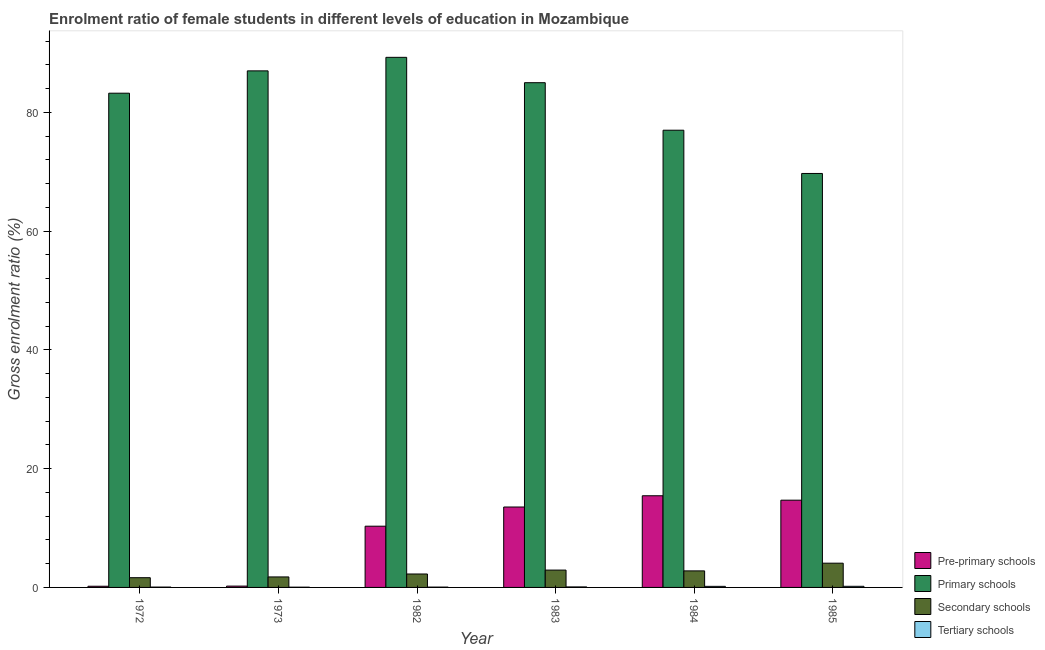How many different coloured bars are there?
Keep it short and to the point. 4. How many groups of bars are there?
Give a very brief answer. 6. Are the number of bars per tick equal to the number of legend labels?
Keep it short and to the point. Yes. How many bars are there on the 4th tick from the left?
Offer a very short reply. 4. How many bars are there on the 2nd tick from the right?
Your answer should be compact. 4. What is the label of the 2nd group of bars from the left?
Make the answer very short. 1973. What is the gross enrolment ratio(male) in primary schools in 1973?
Ensure brevity in your answer.  87. Across all years, what is the maximum gross enrolment ratio(male) in pre-primary schools?
Keep it short and to the point. 15.44. Across all years, what is the minimum gross enrolment ratio(male) in secondary schools?
Ensure brevity in your answer.  1.64. What is the total gross enrolment ratio(male) in pre-primary schools in the graph?
Make the answer very short. 54.41. What is the difference between the gross enrolment ratio(male) in primary schools in 1984 and that in 1985?
Give a very brief answer. 7.28. What is the difference between the gross enrolment ratio(male) in primary schools in 1984 and the gross enrolment ratio(male) in secondary schools in 1973?
Ensure brevity in your answer.  -10. What is the average gross enrolment ratio(male) in primary schools per year?
Your answer should be very brief. 81.88. In the year 1973, what is the difference between the gross enrolment ratio(male) in pre-primary schools and gross enrolment ratio(male) in secondary schools?
Provide a short and direct response. 0. In how many years, is the gross enrolment ratio(male) in secondary schools greater than 16 %?
Your answer should be very brief. 0. What is the ratio of the gross enrolment ratio(male) in tertiary schools in 1972 to that in 1983?
Make the answer very short. 0.68. Is the gross enrolment ratio(male) in pre-primary schools in 1972 less than that in 1983?
Your answer should be very brief. Yes. Is the difference between the gross enrolment ratio(male) in pre-primary schools in 1983 and 1984 greater than the difference between the gross enrolment ratio(male) in secondary schools in 1983 and 1984?
Give a very brief answer. No. What is the difference between the highest and the second highest gross enrolment ratio(male) in tertiary schools?
Keep it short and to the point. 0.01. What is the difference between the highest and the lowest gross enrolment ratio(male) in primary schools?
Make the answer very short. 19.56. Is the sum of the gross enrolment ratio(male) in primary schools in 1973 and 1982 greater than the maximum gross enrolment ratio(male) in tertiary schools across all years?
Provide a succinct answer. Yes. Is it the case that in every year, the sum of the gross enrolment ratio(male) in tertiary schools and gross enrolment ratio(male) in secondary schools is greater than the sum of gross enrolment ratio(male) in primary schools and gross enrolment ratio(male) in pre-primary schools?
Keep it short and to the point. No. What does the 2nd bar from the left in 1982 represents?
Provide a succinct answer. Primary schools. What does the 3rd bar from the right in 1985 represents?
Your answer should be very brief. Primary schools. How many bars are there?
Ensure brevity in your answer.  24. Are all the bars in the graph horizontal?
Ensure brevity in your answer.  No. How many years are there in the graph?
Keep it short and to the point. 6. Does the graph contain grids?
Provide a succinct answer. No. How many legend labels are there?
Your answer should be very brief. 4. What is the title of the graph?
Make the answer very short. Enrolment ratio of female students in different levels of education in Mozambique. What is the label or title of the Y-axis?
Offer a terse response. Gross enrolment ratio (%). What is the Gross enrolment ratio (%) of Pre-primary schools in 1972?
Give a very brief answer. 0.2. What is the Gross enrolment ratio (%) of Primary schools in 1972?
Offer a terse response. 83.24. What is the Gross enrolment ratio (%) of Secondary schools in 1972?
Offer a very short reply. 1.64. What is the Gross enrolment ratio (%) in Tertiary schools in 1972?
Your answer should be very brief. 0.06. What is the Gross enrolment ratio (%) in Pre-primary schools in 1973?
Your response must be concise. 0.22. What is the Gross enrolment ratio (%) in Primary schools in 1973?
Your answer should be compact. 87. What is the Gross enrolment ratio (%) of Secondary schools in 1973?
Make the answer very short. 1.77. What is the Gross enrolment ratio (%) in Tertiary schools in 1973?
Provide a succinct answer. 0.04. What is the Gross enrolment ratio (%) of Pre-primary schools in 1982?
Offer a very short reply. 10.31. What is the Gross enrolment ratio (%) in Primary schools in 1982?
Ensure brevity in your answer.  89.28. What is the Gross enrolment ratio (%) of Secondary schools in 1982?
Your answer should be compact. 2.26. What is the Gross enrolment ratio (%) in Tertiary schools in 1982?
Give a very brief answer. 0.05. What is the Gross enrolment ratio (%) of Pre-primary schools in 1983?
Your answer should be compact. 13.54. What is the Gross enrolment ratio (%) of Primary schools in 1983?
Your response must be concise. 85.01. What is the Gross enrolment ratio (%) of Secondary schools in 1983?
Your response must be concise. 2.92. What is the Gross enrolment ratio (%) of Tertiary schools in 1983?
Your answer should be very brief. 0.09. What is the Gross enrolment ratio (%) of Pre-primary schools in 1984?
Offer a terse response. 15.44. What is the Gross enrolment ratio (%) in Primary schools in 1984?
Provide a short and direct response. 77. What is the Gross enrolment ratio (%) of Secondary schools in 1984?
Make the answer very short. 2.79. What is the Gross enrolment ratio (%) of Tertiary schools in 1984?
Offer a very short reply. 0.18. What is the Gross enrolment ratio (%) in Pre-primary schools in 1985?
Keep it short and to the point. 14.7. What is the Gross enrolment ratio (%) of Primary schools in 1985?
Ensure brevity in your answer.  69.72. What is the Gross enrolment ratio (%) in Secondary schools in 1985?
Keep it short and to the point. 4.08. What is the Gross enrolment ratio (%) of Tertiary schools in 1985?
Make the answer very short. 0.19. Across all years, what is the maximum Gross enrolment ratio (%) in Pre-primary schools?
Your answer should be very brief. 15.44. Across all years, what is the maximum Gross enrolment ratio (%) in Primary schools?
Provide a short and direct response. 89.28. Across all years, what is the maximum Gross enrolment ratio (%) in Secondary schools?
Offer a very short reply. 4.08. Across all years, what is the maximum Gross enrolment ratio (%) in Tertiary schools?
Ensure brevity in your answer.  0.19. Across all years, what is the minimum Gross enrolment ratio (%) of Pre-primary schools?
Your response must be concise. 0.2. Across all years, what is the minimum Gross enrolment ratio (%) of Primary schools?
Ensure brevity in your answer.  69.72. Across all years, what is the minimum Gross enrolment ratio (%) in Secondary schools?
Provide a short and direct response. 1.64. Across all years, what is the minimum Gross enrolment ratio (%) of Tertiary schools?
Ensure brevity in your answer.  0.04. What is the total Gross enrolment ratio (%) of Pre-primary schools in the graph?
Your answer should be compact. 54.41. What is the total Gross enrolment ratio (%) of Primary schools in the graph?
Give a very brief answer. 491.25. What is the total Gross enrolment ratio (%) in Secondary schools in the graph?
Provide a short and direct response. 15.46. What is the total Gross enrolment ratio (%) of Tertiary schools in the graph?
Provide a succinct answer. 0.61. What is the difference between the Gross enrolment ratio (%) in Pre-primary schools in 1972 and that in 1973?
Keep it short and to the point. -0.02. What is the difference between the Gross enrolment ratio (%) in Primary schools in 1972 and that in 1973?
Offer a terse response. -3.76. What is the difference between the Gross enrolment ratio (%) in Secondary schools in 1972 and that in 1973?
Provide a short and direct response. -0.13. What is the difference between the Gross enrolment ratio (%) of Tertiary schools in 1972 and that in 1973?
Provide a short and direct response. 0.02. What is the difference between the Gross enrolment ratio (%) in Pre-primary schools in 1972 and that in 1982?
Offer a very short reply. -10.11. What is the difference between the Gross enrolment ratio (%) in Primary schools in 1972 and that in 1982?
Your answer should be compact. -6.04. What is the difference between the Gross enrolment ratio (%) in Secondary schools in 1972 and that in 1982?
Provide a short and direct response. -0.62. What is the difference between the Gross enrolment ratio (%) of Tertiary schools in 1972 and that in 1982?
Give a very brief answer. 0. What is the difference between the Gross enrolment ratio (%) of Pre-primary schools in 1972 and that in 1983?
Your response must be concise. -13.34. What is the difference between the Gross enrolment ratio (%) in Primary schools in 1972 and that in 1983?
Make the answer very short. -1.77. What is the difference between the Gross enrolment ratio (%) in Secondary schools in 1972 and that in 1983?
Your response must be concise. -1.28. What is the difference between the Gross enrolment ratio (%) in Tertiary schools in 1972 and that in 1983?
Make the answer very short. -0.03. What is the difference between the Gross enrolment ratio (%) in Pre-primary schools in 1972 and that in 1984?
Your response must be concise. -15.24. What is the difference between the Gross enrolment ratio (%) of Primary schools in 1972 and that in 1984?
Your answer should be very brief. 6.24. What is the difference between the Gross enrolment ratio (%) of Secondary schools in 1972 and that in 1984?
Your answer should be very brief. -1.15. What is the difference between the Gross enrolment ratio (%) in Tertiary schools in 1972 and that in 1984?
Give a very brief answer. -0.12. What is the difference between the Gross enrolment ratio (%) in Pre-primary schools in 1972 and that in 1985?
Keep it short and to the point. -14.5. What is the difference between the Gross enrolment ratio (%) of Primary schools in 1972 and that in 1985?
Make the answer very short. 13.52. What is the difference between the Gross enrolment ratio (%) of Secondary schools in 1972 and that in 1985?
Your answer should be very brief. -2.44. What is the difference between the Gross enrolment ratio (%) of Tertiary schools in 1972 and that in 1985?
Ensure brevity in your answer.  -0.13. What is the difference between the Gross enrolment ratio (%) in Pre-primary schools in 1973 and that in 1982?
Ensure brevity in your answer.  -10.09. What is the difference between the Gross enrolment ratio (%) of Primary schools in 1973 and that in 1982?
Give a very brief answer. -2.28. What is the difference between the Gross enrolment ratio (%) in Secondary schools in 1973 and that in 1982?
Your response must be concise. -0.5. What is the difference between the Gross enrolment ratio (%) of Tertiary schools in 1973 and that in 1982?
Offer a very short reply. -0.01. What is the difference between the Gross enrolment ratio (%) in Pre-primary schools in 1973 and that in 1983?
Provide a short and direct response. -13.32. What is the difference between the Gross enrolment ratio (%) in Primary schools in 1973 and that in 1983?
Provide a succinct answer. 1.99. What is the difference between the Gross enrolment ratio (%) of Secondary schools in 1973 and that in 1983?
Provide a succinct answer. -1.15. What is the difference between the Gross enrolment ratio (%) of Tertiary schools in 1973 and that in 1983?
Provide a succinct answer. -0.04. What is the difference between the Gross enrolment ratio (%) in Pre-primary schools in 1973 and that in 1984?
Your answer should be very brief. -15.22. What is the difference between the Gross enrolment ratio (%) of Primary schools in 1973 and that in 1984?
Give a very brief answer. 10. What is the difference between the Gross enrolment ratio (%) of Secondary schools in 1973 and that in 1984?
Offer a terse response. -1.02. What is the difference between the Gross enrolment ratio (%) in Tertiary schools in 1973 and that in 1984?
Provide a succinct answer. -0.14. What is the difference between the Gross enrolment ratio (%) of Pre-primary schools in 1973 and that in 1985?
Offer a terse response. -14.47. What is the difference between the Gross enrolment ratio (%) in Primary schools in 1973 and that in 1985?
Ensure brevity in your answer.  17.28. What is the difference between the Gross enrolment ratio (%) of Secondary schools in 1973 and that in 1985?
Give a very brief answer. -2.31. What is the difference between the Gross enrolment ratio (%) of Tertiary schools in 1973 and that in 1985?
Your answer should be very brief. -0.15. What is the difference between the Gross enrolment ratio (%) of Pre-primary schools in 1982 and that in 1983?
Your answer should be compact. -3.23. What is the difference between the Gross enrolment ratio (%) of Primary schools in 1982 and that in 1983?
Offer a very short reply. 4.27. What is the difference between the Gross enrolment ratio (%) in Secondary schools in 1982 and that in 1983?
Keep it short and to the point. -0.66. What is the difference between the Gross enrolment ratio (%) of Tertiary schools in 1982 and that in 1983?
Make the answer very short. -0.03. What is the difference between the Gross enrolment ratio (%) of Pre-primary schools in 1982 and that in 1984?
Give a very brief answer. -5.12. What is the difference between the Gross enrolment ratio (%) in Primary schools in 1982 and that in 1984?
Offer a terse response. 12.27. What is the difference between the Gross enrolment ratio (%) of Secondary schools in 1982 and that in 1984?
Offer a very short reply. -0.52. What is the difference between the Gross enrolment ratio (%) in Tertiary schools in 1982 and that in 1984?
Your answer should be very brief. -0.13. What is the difference between the Gross enrolment ratio (%) in Pre-primary schools in 1982 and that in 1985?
Make the answer very short. -4.38. What is the difference between the Gross enrolment ratio (%) of Primary schools in 1982 and that in 1985?
Keep it short and to the point. 19.56. What is the difference between the Gross enrolment ratio (%) in Secondary schools in 1982 and that in 1985?
Provide a short and direct response. -1.82. What is the difference between the Gross enrolment ratio (%) of Tertiary schools in 1982 and that in 1985?
Your response must be concise. -0.14. What is the difference between the Gross enrolment ratio (%) of Pre-primary schools in 1983 and that in 1984?
Give a very brief answer. -1.89. What is the difference between the Gross enrolment ratio (%) of Primary schools in 1983 and that in 1984?
Your response must be concise. 8. What is the difference between the Gross enrolment ratio (%) in Secondary schools in 1983 and that in 1984?
Give a very brief answer. 0.13. What is the difference between the Gross enrolment ratio (%) in Tertiary schools in 1983 and that in 1984?
Provide a succinct answer. -0.1. What is the difference between the Gross enrolment ratio (%) in Pre-primary schools in 1983 and that in 1985?
Provide a succinct answer. -1.15. What is the difference between the Gross enrolment ratio (%) of Primary schools in 1983 and that in 1985?
Offer a terse response. 15.29. What is the difference between the Gross enrolment ratio (%) of Secondary schools in 1983 and that in 1985?
Provide a short and direct response. -1.16. What is the difference between the Gross enrolment ratio (%) of Tertiary schools in 1983 and that in 1985?
Offer a very short reply. -0.1. What is the difference between the Gross enrolment ratio (%) of Pre-primary schools in 1984 and that in 1985?
Provide a succinct answer. 0.74. What is the difference between the Gross enrolment ratio (%) of Primary schools in 1984 and that in 1985?
Provide a short and direct response. 7.28. What is the difference between the Gross enrolment ratio (%) in Secondary schools in 1984 and that in 1985?
Provide a succinct answer. -1.3. What is the difference between the Gross enrolment ratio (%) in Tertiary schools in 1984 and that in 1985?
Offer a terse response. -0.01. What is the difference between the Gross enrolment ratio (%) of Pre-primary schools in 1972 and the Gross enrolment ratio (%) of Primary schools in 1973?
Ensure brevity in your answer.  -86.8. What is the difference between the Gross enrolment ratio (%) of Pre-primary schools in 1972 and the Gross enrolment ratio (%) of Secondary schools in 1973?
Provide a succinct answer. -1.57. What is the difference between the Gross enrolment ratio (%) in Pre-primary schools in 1972 and the Gross enrolment ratio (%) in Tertiary schools in 1973?
Give a very brief answer. 0.16. What is the difference between the Gross enrolment ratio (%) in Primary schools in 1972 and the Gross enrolment ratio (%) in Secondary schools in 1973?
Make the answer very short. 81.47. What is the difference between the Gross enrolment ratio (%) of Primary schools in 1972 and the Gross enrolment ratio (%) of Tertiary schools in 1973?
Provide a succinct answer. 83.2. What is the difference between the Gross enrolment ratio (%) in Secondary schools in 1972 and the Gross enrolment ratio (%) in Tertiary schools in 1973?
Make the answer very short. 1.6. What is the difference between the Gross enrolment ratio (%) in Pre-primary schools in 1972 and the Gross enrolment ratio (%) in Primary schools in 1982?
Offer a very short reply. -89.08. What is the difference between the Gross enrolment ratio (%) of Pre-primary schools in 1972 and the Gross enrolment ratio (%) of Secondary schools in 1982?
Your answer should be compact. -2.06. What is the difference between the Gross enrolment ratio (%) of Pre-primary schools in 1972 and the Gross enrolment ratio (%) of Tertiary schools in 1982?
Give a very brief answer. 0.15. What is the difference between the Gross enrolment ratio (%) in Primary schools in 1972 and the Gross enrolment ratio (%) in Secondary schools in 1982?
Give a very brief answer. 80.98. What is the difference between the Gross enrolment ratio (%) in Primary schools in 1972 and the Gross enrolment ratio (%) in Tertiary schools in 1982?
Give a very brief answer. 83.19. What is the difference between the Gross enrolment ratio (%) in Secondary schools in 1972 and the Gross enrolment ratio (%) in Tertiary schools in 1982?
Provide a succinct answer. 1.58. What is the difference between the Gross enrolment ratio (%) in Pre-primary schools in 1972 and the Gross enrolment ratio (%) in Primary schools in 1983?
Keep it short and to the point. -84.81. What is the difference between the Gross enrolment ratio (%) of Pre-primary schools in 1972 and the Gross enrolment ratio (%) of Secondary schools in 1983?
Your answer should be very brief. -2.72. What is the difference between the Gross enrolment ratio (%) of Pre-primary schools in 1972 and the Gross enrolment ratio (%) of Tertiary schools in 1983?
Offer a very short reply. 0.11. What is the difference between the Gross enrolment ratio (%) of Primary schools in 1972 and the Gross enrolment ratio (%) of Secondary schools in 1983?
Keep it short and to the point. 80.32. What is the difference between the Gross enrolment ratio (%) of Primary schools in 1972 and the Gross enrolment ratio (%) of Tertiary schools in 1983?
Offer a very short reply. 83.15. What is the difference between the Gross enrolment ratio (%) in Secondary schools in 1972 and the Gross enrolment ratio (%) in Tertiary schools in 1983?
Give a very brief answer. 1.55. What is the difference between the Gross enrolment ratio (%) in Pre-primary schools in 1972 and the Gross enrolment ratio (%) in Primary schools in 1984?
Your answer should be very brief. -76.8. What is the difference between the Gross enrolment ratio (%) in Pre-primary schools in 1972 and the Gross enrolment ratio (%) in Secondary schools in 1984?
Offer a terse response. -2.59. What is the difference between the Gross enrolment ratio (%) of Pre-primary schools in 1972 and the Gross enrolment ratio (%) of Tertiary schools in 1984?
Offer a very short reply. 0.02. What is the difference between the Gross enrolment ratio (%) of Primary schools in 1972 and the Gross enrolment ratio (%) of Secondary schools in 1984?
Provide a short and direct response. 80.45. What is the difference between the Gross enrolment ratio (%) in Primary schools in 1972 and the Gross enrolment ratio (%) in Tertiary schools in 1984?
Provide a succinct answer. 83.06. What is the difference between the Gross enrolment ratio (%) of Secondary schools in 1972 and the Gross enrolment ratio (%) of Tertiary schools in 1984?
Keep it short and to the point. 1.46. What is the difference between the Gross enrolment ratio (%) of Pre-primary schools in 1972 and the Gross enrolment ratio (%) of Primary schools in 1985?
Offer a terse response. -69.52. What is the difference between the Gross enrolment ratio (%) in Pre-primary schools in 1972 and the Gross enrolment ratio (%) in Secondary schools in 1985?
Offer a very short reply. -3.88. What is the difference between the Gross enrolment ratio (%) of Pre-primary schools in 1972 and the Gross enrolment ratio (%) of Tertiary schools in 1985?
Ensure brevity in your answer.  0.01. What is the difference between the Gross enrolment ratio (%) of Primary schools in 1972 and the Gross enrolment ratio (%) of Secondary schools in 1985?
Provide a short and direct response. 79.16. What is the difference between the Gross enrolment ratio (%) in Primary schools in 1972 and the Gross enrolment ratio (%) in Tertiary schools in 1985?
Your answer should be very brief. 83.05. What is the difference between the Gross enrolment ratio (%) in Secondary schools in 1972 and the Gross enrolment ratio (%) in Tertiary schools in 1985?
Provide a short and direct response. 1.45. What is the difference between the Gross enrolment ratio (%) of Pre-primary schools in 1973 and the Gross enrolment ratio (%) of Primary schools in 1982?
Your answer should be very brief. -89.06. What is the difference between the Gross enrolment ratio (%) of Pre-primary schools in 1973 and the Gross enrolment ratio (%) of Secondary schools in 1982?
Your answer should be very brief. -2.04. What is the difference between the Gross enrolment ratio (%) of Pre-primary schools in 1973 and the Gross enrolment ratio (%) of Tertiary schools in 1982?
Make the answer very short. 0.17. What is the difference between the Gross enrolment ratio (%) of Primary schools in 1973 and the Gross enrolment ratio (%) of Secondary schools in 1982?
Offer a very short reply. 84.74. What is the difference between the Gross enrolment ratio (%) in Primary schools in 1973 and the Gross enrolment ratio (%) in Tertiary schools in 1982?
Your answer should be very brief. 86.95. What is the difference between the Gross enrolment ratio (%) in Secondary schools in 1973 and the Gross enrolment ratio (%) in Tertiary schools in 1982?
Your answer should be compact. 1.71. What is the difference between the Gross enrolment ratio (%) in Pre-primary schools in 1973 and the Gross enrolment ratio (%) in Primary schools in 1983?
Make the answer very short. -84.79. What is the difference between the Gross enrolment ratio (%) of Pre-primary schools in 1973 and the Gross enrolment ratio (%) of Secondary schools in 1983?
Provide a short and direct response. -2.7. What is the difference between the Gross enrolment ratio (%) of Pre-primary schools in 1973 and the Gross enrolment ratio (%) of Tertiary schools in 1983?
Keep it short and to the point. 0.14. What is the difference between the Gross enrolment ratio (%) in Primary schools in 1973 and the Gross enrolment ratio (%) in Secondary schools in 1983?
Your answer should be compact. 84.08. What is the difference between the Gross enrolment ratio (%) in Primary schools in 1973 and the Gross enrolment ratio (%) in Tertiary schools in 1983?
Your response must be concise. 86.91. What is the difference between the Gross enrolment ratio (%) of Secondary schools in 1973 and the Gross enrolment ratio (%) of Tertiary schools in 1983?
Provide a succinct answer. 1.68. What is the difference between the Gross enrolment ratio (%) in Pre-primary schools in 1973 and the Gross enrolment ratio (%) in Primary schools in 1984?
Make the answer very short. -76.78. What is the difference between the Gross enrolment ratio (%) in Pre-primary schools in 1973 and the Gross enrolment ratio (%) in Secondary schools in 1984?
Your answer should be compact. -2.56. What is the difference between the Gross enrolment ratio (%) of Pre-primary schools in 1973 and the Gross enrolment ratio (%) of Tertiary schools in 1984?
Your answer should be very brief. 0.04. What is the difference between the Gross enrolment ratio (%) of Primary schools in 1973 and the Gross enrolment ratio (%) of Secondary schools in 1984?
Your response must be concise. 84.21. What is the difference between the Gross enrolment ratio (%) in Primary schools in 1973 and the Gross enrolment ratio (%) in Tertiary schools in 1984?
Offer a terse response. 86.82. What is the difference between the Gross enrolment ratio (%) of Secondary schools in 1973 and the Gross enrolment ratio (%) of Tertiary schools in 1984?
Offer a very short reply. 1.59. What is the difference between the Gross enrolment ratio (%) of Pre-primary schools in 1973 and the Gross enrolment ratio (%) of Primary schools in 1985?
Your response must be concise. -69.5. What is the difference between the Gross enrolment ratio (%) of Pre-primary schools in 1973 and the Gross enrolment ratio (%) of Secondary schools in 1985?
Offer a very short reply. -3.86. What is the difference between the Gross enrolment ratio (%) of Pre-primary schools in 1973 and the Gross enrolment ratio (%) of Tertiary schools in 1985?
Offer a terse response. 0.03. What is the difference between the Gross enrolment ratio (%) in Primary schools in 1973 and the Gross enrolment ratio (%) in Secondary schools in 1985?
Provide a short and direct response. 82.92. What is the difference between the Gross enrolment ratio (%) in Primary schools in 1973 and the Gross enrolment ratio (%) in Tertiary schools in 1985?
Your answer should be compact. 86.81. What is the difference between the Gross enrolment ratio (%) of Secondary schools in 1973 and the Gross enrolment ratio (%) of Tertiary schools in 1985?
Offer a terse response. 1.58. What is the difference between the Gross enrolment ratio (%) of Pre-primary schools in 1982 and the Gross enrolment ratio (%) of Primary schools in 1983?
Provide a succinct answer. -74.69. What is the difference between the Gross enrolment ratio (%) in Pre-primary schools in 1982 and the Gross enrolment ratio (%) in Secondary schools in 1983?
Your answer should be very brief. 7.39. What is the difference between the Gross enrolment ratio (%) in Pre-primary schools in 1982 and the Gross enrolment ratio (%) in Tertiary schools in 1983?
Provide a succinct answer. 10.23. What is the difference between the Gross enrolment ratio (%) in Primary schools in 1982 and the Gross enrolment ratio (%) in Secondary schools in 1983?
Provide a short and direct response. 86.36. What is the difference between the Gross enrolment ratio (%) of Primary schools in 1982 and the Gross enrolment ratio (%) of Tertiary schools in 1983?
Provide a short and direct response. 89.19. What is the difference between the Gross enrolment ratio (%) in Secondary schools in 1982 and the Gross enrolment ratio (%) in Tertiary schools in 1983?
Your answer should be compact. 2.18. What is the difference between the Gross enrolment ratio (%) of Pre-primary schools in 1982 and the Gross enrolment ratio (%) of Primary schools in 1984?
Your answer should be very brief. -66.69. What is the difference between the Gross enrolment ratio (%) of Pre-primary schools in 1982 and the Gross enrolment ratio (%) of Secondary schools in 1984?
Provide a succinct answer. 7.53. What is the difference between the Gross enrolment ratio (%) of Pre-primary schools in 1982 and the Gross enrolment ratio (%) of Tertiary schools in 1984?
Your response must be concise. 10.13. What is the difference between the Gross enrolment ratio (%) in Primary schools in 1982 and the Gross enrolment ratio (%) in Secondary schools in 1984?
Give a very brief answer. 86.49. What is the difference between the Gross enrolment ratio (%) of Primary schools in 1982 and the Gross enrolment ratio (%) of Tertiary schools in 1984?
Your answer should be very brief. 89.1. What is the difference between the Gross enrolment ratio (%) of Secondary schools in 1982 and the Gross enrolment ratio (%) of Tertiary schools in 1984?
Offer a terse response. 2.08. What is the difference between the Gross enrolment ratio (%) of Pre-primary schools in 1982 and the Gross enrolment ratio (%) of Primary schools in 1985?
Make the answer very short. -59.41. What is the difference between the Gross enrolment ratio (%) in Pre-primary schools in 1982 and the Gross enrolment ratio (%) in Secondary schools in 1985?
Ensure brevity in your answer.  6.23. What is the difference between the Gross enrolment ratio (%) of Pre-primary schools in 1982 and the Gross enrolment ratio (%) of Tertiary schools in 1985?
Provide a succinct answer. 10.12. What is the difference between the Gross enrolment ratio (%) of Primary schools in 1982 and the Gross enrolment ratio (%) of Secondary schools in 1985?
Your response must be concise. 85.2. What is the difference between the Gross enrolment ratio (%) in Primary schools in 1982 and the Gross enrolment ratio (%) in Tertiary schools in 1985?
Ensure brevity in your answer.  89.09. What is the difference between the Gross enrolment ratio (%) in Secondary schools in 1982 and the Gross enrolment ratio (%) in Tertiary schools in 1985?
Provide a short and direct response. 2.07. What is the difference between the Gross enrolment ratio (%) in Pre-primary schools in 1983 and the Gross enrolment ratio (%) in Primary schools in 1984?
Keep it short and to the point. -63.46. What is the difference between the Gross enrolment ratio (%) of Pre-primary schools in 1983 and the Gross enrolment ratio (%) of Secondary schools in 1984?
Keep it short and to the point. 10.76. What is the difference between the Gross enrolment ratio (%) in Pre-primary schools in 1983 and the Gross enrolment ratio (%) in Tertiary schools in 1984?
Make the answer very short. 13.36. What is the difference between the Gross enrolment ratio (%) of Primary schools in 1983 and the Gross enrolment ratio (%) of Secondary schools in 1984?
Make the answer very short. 82.22. What is the difference between the Gross enrolment ratio (%) in Primary schools in 1983 and the Gross enrolment ratio (%) in Tertiary schools in 1984?
Provide a succinct answer. 84.83. What is the difference between the Gross enrolment ratio (%) in Secondary schools in 1983 and the Gross enrolment ratio (%) in Tertiary schools in 1984?
Make the answer very short. 2.74. What is the difference between the Gross enrolment ratio (%) in Pre-primary schools in 1983 and the Gross enrolment ratio (%) in Primary schools in 1985?
Ensure brevity in your answer.  -56.18. What is the difference between the Gross enrolment ratio (%) of Pre-primary schools in 1983 and the Gross enrolment ratio (%) of Secondary schools in 1985?
Your response must be concise. 9.46. What is the difference between the Gross enrolment ratio (%) in Pre-primary schools in 1983 and the Gross enrolment ratio (%) in Tertiary schools in 1985?
Ensure brevity in your answer.  13.35. What is the difference between the Gross enrolment ratio (%) in Primary schools in 1983 and the Gross enrolment ratio (%) in Secondary schools in 1985?
Ensure brevity in your answer.  80.93. What is the difference between the Gross enrolment ratio (%) of Primary schools in 1983 and the Gross enrolment ratio (%) of Tertiary schools in 1985?
Your response must be concise. 84.82. What is the difference between the Gross enrolment ratio (%) in Secondary schools in 1983 and the Gross enrolment ratio (%) in Tertiary schools in 1985?
Your answer should be compact. 2.73. What is the difference between the Gross enrolment ratio (%) of Pre-primary schools in 1984 and the Gross enrolment ratio (%) of Primary schools in 1985?
Your answer should be very brief. -54.28. What is the difference between the Gross enrolment ratio (%) of Pre-primary schools in 1984 and the Gross enrolment ratio (%) of Secondary schools in 1985?
Give a very brief answer. 11.36. What is the difference between the Gross enrolment ratio (%) in Pre-primary schools in 1984 and the Gross enrolment ratio (%) in Tertiary schools in 1985?
Your answer should be compact. 15.25. What is the difference between the Gross enrolment ratio (%) of Primary schools in 1984 and the Gross enrolment ratio (%) of Secondary schools in 1985?
Offer a very short reply. 72.92. What is the difference between the Gross enrolment ratio (%) of Primary schools in 1984 and the Gross enrolment ratio (%) of Tertiary schools in 1985?
Your answer should be compact. 76.81. What is the difference between the Gross enrolment ratio (%) in Secondary schools in 1984 and the Gross enrolment ratio (%) in Tertiary schools in 1985?
Your answer should be very brief. 2.6. What is the average Gross enrolment ratio (%) in Pre-primary schools per year?
Your response must be concise. 9.07. What is the average Gross enrolment ratio (%) in Primary schools per year?
Ensure brevity in your answer.  81.88. What is the average Gross enrolment ratio (%) in Secondary schools per year?
Your response must be concise. 2.58. What is the average Gross enrolment ratio (%) in Tertiary schools per year?
Your response must be concise. 0.1. In the year 1972, what is the difference between the Gross enrolment ratio (%) of Pre-primary schools and Gross enrolment ratio (%) of Primary schools?
Your answer should be compact. -83.04. In the year 1972, what is the difference between the Gross enrolment ratio (%) of Pre-primary schools and Gross enrolment ratio (%) of Secondary schools?
Ensure brevity in your answer.  -1.44. In the year 1972, what is the difference between the Gross enrolment ratio (%) in Pre-primary schools and Gross enrolment ratio (%) in Tertiary schools?
Offer a very short reply. 0.14. In the year 1972, what is the difference between the Gross enrolment ratio (%) of Primary schools and Gross enrolment ratio (%) of Secondary schools?
Your answer should be compact. 81.6. In the year 1972, what is the difference between the Gross enrolment ratio (%) in Primary schools and Gross enrolment ratio (%) in Tertiary schools?
Make the answer very short. 83.18. In the year 1972, what is the difference between the Gross enrolment ratio (%) of Secondary schools and Gross enrolment ratio (%) of Tertiary schools?
Make the answer very short. 1.58. In the year 1973, what is the difference between the Gross enrolment ratio (%) in Pre-primary schools and Gross enrolment ratio (%) in Primary schools?
Your answer should be very brief. -86.78. In the year 1973, what is the difference between the Gross enrolment ratio (%) in Pre-primary schools and Gross enrolment ratio (%) in Secondary schools?
Offer a very short reply. -1.55. In the year 1973, what is the difference between the Gross enrolment ratio (%) of Pre-primary schools and Gross enrolment ratio (%) of Tertiary schools?
Your answer should be compact. 0.18. In the year 1973, what is the difference between the Gross enrolment ratio (%) in Primary schools and Gross enrolment ratio (%) in Secondary schools?
Give a very brief answer. 85.23. In the year 1973, what is the difference between the Gross enrolment ratio (%) of Primary schools and Gross enrolment ratio (%) of Tertiary schools?
Your response must be concise. 86.96. In the year 1973, what is the difference between the Gross enrolment ratio (%) of Secondary schools and Gross enrolment ratio (%) of Tertiary schools?
Offer a terse response. 1.73. In the year 1982, what is the difference between the Gross enrolment ratio (%) of Pre-primary schools and Gross enrolment ratio (%) of Primary schools?
Provide a short and direct response. -78.97. In the year 1982, what is the difference between the Gross enrolment ratio (%) of Pre-primary schools and Gross enrolment ratio (%) of Secondary schools?
Offer a very short reply. 8.05. In the year 1982, what is the difference between the Gross enrolment ratio (%) in Pre-primary schools and Gross enrolment ratio (%) in Tertiary schools?
Your answer should be very brief. 10.26. In the year 1982, what is the difference between the Gross enrolment ratio (%) of Primary schools and Gross enrolment ratio (%) of Secondary schools?
Provide a succinct answer. 87.02. In the year 1982, what is the difference between the Gross enrolment ratio (%) in Primary schools and Gross enrolment ratio (%) in Tertiary schools?
Your response must be concise. 89.23. In the year 1982, what is the difference between the Gross enrolment ratio (%) in Secondary schools and Gross enrolment ratio (%) in Tertiary schools?
Give a very brief answer. 2.21. In the year 1983, what is the difference between the Gross enrolment ratio (%) in Pre-primary schools and Gross enrolment ratio (%) in Primary schools?
Offer a terse response. -71.46. In the year 1983, what is the difference between the Gross enrolment ratio (%) in Pre-primary schools and Gross enrolment ratio (%) in Secondary schools?
Ensure brevity in your answer.  10.62. In the year 1983, what is the difference between the Gross enrolment ratio (%) of Pre-primary schools and Gross enrolment ratio (%) of Tertiary schools?
Your answer should be very brief. 13.46. In the year 1983, what is the difference between the Gross enrolment ratio (%) in Primary schools and Gross enrolment ratio (%) in Secondary schools?
Offer a very short reply. 82.09. In the year 1983, what is the difference between the Gross enrolment ratio (%) in Primary schools and Gross enrolment ratio (%) in Tertiary schools?
Keep it short and to the point. 84.92. In the year 1983, what is the difference between the Gross enrolment ratio (%) in Secondary schools and Gross enrolment ratio (%) in Tertiary schools?
Your response must be concise. 2.83. In the year 1984, what is the difference between the Gross enrolment ratio (%) in Pre-primary schools and Gross enrolment ratio (%) in Primary schools?
Your response must be concise. -61.57. In the year 1984, what is the difference between the Gross enrolment ratio (%) of Pre-primary schools and Gross enrolment ratio (%) of Secondary schools?
Your answer should be compact. 12.65. In the year 1984, what is the difference between the Gross enrolment ratio (%) in Pre-primary schools and Gross enrolment ratio (%) in Tertiary schools?
Ensure brevity in your answer.  15.26. In the year 1984, what is the difference between the Gross enrolment ratio (%) in Primary schools and Gross enrolment ratio (%) in Secondary schools?
Your answer should be compact. 74.22. In the year 1984, what is the difference between the Gross enrolment ratio (%) of Primary schools and Gross enrolment ratio (%) of Tertiary schools?
Your answer should be very brief. 76.82. In the year 1984, what is the difference between the Gross enrolment ratio (%) of Secondary schools and Gross enrolment ratio (%) of Tertiary schools?
Keep it short and to the point. 2.6. In the year 1985, what is the difference between the Gross enrolment ratio (%) of Pre-primary schools and Gross enrolment ratio (%) of Primary schools?
Make the answer very short. -55.02. In the year 1985, what is the difference between the Gross enrolment ratio (%) in Pre-primary schools and Gross enrolment ratio (%) in Secondary schools?
Keep it short and to the point. 10.61. In the year 1985, what is the difference between the Gross enrolment ratio (%) in Pre-primary schools and Gross enrolment ratio (%) in Tertiary schools?
Make the answer very short. 14.51. In the year 1985, what is the difference between the Gross enrolment ratio (%) of Primary schools and Gross enrolment ratio (%) of Secondary schools?
Make the answer very short. 65.64. In the year 1985, what is the difference between the Gross enrolment ratio (%) of Primary schools and Gross enrolment ratio (%) of Tertiary schools?
Offer a very short reply. 69.53. In the year 1985, what is the difference between the Gross enrolment ratio (%) in Secondary schools and Gross enrolment ratio (%) in Tertiary schools?
Your answer should be very brief. 3.89. What is the ratio of the Gross enrolment ratio (%) of Pre-primary schools in 1972 to that in 1973?
Offer a terse response. 0.9. What is the ratio of the Gross enrolment ratio (%) in Primary schools in 1972 to that in 1973?
Your answer should be compact. 0.96. What is the ratio of the Gross enrolment ratio (%) in Secondary schools in 1972 to that in 1973?
Offer a terse response. 0.93. What is the ratio of the Gross enrolment ratio (%) of Tertiary schools in 1972 to that in 1973?
Ensure brevity in your answer.  1.42. What is the ratio of the Gross enrolment ratio (%) of Pre-primary schools in 1972 to that in 1982?
Your answer should be very brief. 0.02. What is the ratio of the Gross enrolment ratio (%) in Primary schools in 1972 to that in 1982?
Offer a very short reply. 0.93. What is the ratio of the Gross enrolment ratio (%) in Secondary schools in 1972 to that in 1982?
Provide a short and direct response. 0.72. What is the ratio of the Gross enrolment ratio (%) of Tertiary schools in 1972 to that in 1982?
Offer a very short reply. 1.08. What is the ratio of the Gross enrolment ratio (%) in Pre-primary schools in 1972 to that in 1983?
Provide a short and direct response. 0.01. What is the ratio of the Gross enrolment ratio (%) of Primary schools in 1972 to that in 1983?
Offer a very short reply. 0.98. What is the ratio of the Gross enrolment ratio (%) in Secondary schools in 1972 to that in 1983?
Your answer should be compact. 0.56. What is the ratio of the Gross enrolment ratio (%) in Tertiary schools in 1972 to that in 1983?
Offer a very short reply. 0.68. What is the ratio of the Gross enrolment ratio (%) in Pre-primary schools in 1972 to that in 1984?
Your answer should be compact. 0.01. What is the ratio of the Gross enrolment ratio (%) in Primary schools in 1972 to that in 1984?
Give a very brief answer. 1.08. What is the ratio of the Gross enrolment ratio (%) of Secondary schools in 1972 to that in 1984?
Keep it short and to the point. 0.59. What is the ratio of the Gross enrolment ratio (%) in Tertiary schools in 1972 to that in 1984?
Your answer should be compact. 0.32. What is the ratio of the Gross enrolment ratio (%) in Pre-primary schools in 1972 to that in 1985?
Provide a short and direct response. 0.01. What is the ratio of the Gross enrolment ratio (%) of Primary schools in 1972 to that in 1985?
Your answer should be compact. 1.19. What is the ratio of the Gross enrolment ratio (%) in Secondary schools in 1972 to that in 1985?
Your answer should be compact. 0.4. What is the ratio of the Gross enrolment ratio (%) in Tertiary schools in 1972 to that in 1985?
Offer a terse response. 0.31. What is the ratio of the Gross enrolment ratio (%) in Pre-primary schools in 1973 to that in 1982?
Keep it short and to the point. 0.02. What is the ratio of the Gross enrolment ratio (%) of Primary schools in 1973 to that in 1982?
Provide a succinct answer. 0.97. What is the ratio of the Gross enrolment ratio (%) in Secondary schools in 1973 to that in 1982?
Make the answer very short. 0.78. What is the ratio of the Gross enrolment ratio (%) of Tertiary schools in 1973 to that in 1982?
Make the answer very short. 0.76. What is the ratio of the Gross enrolment ratio (%) in Pre-primary schools in 1973 to that in 1983?
Give a very brief answer. 0.02. What is the ratio of the Gross enrolment ratio (%) in Primary schools in 1973 to that in 1983?
Your answer should be compact. 1.02. What is the ratio of the Gross enrolment ratio (%) of Secondary schools in 1973 to that in 1983?
Provide a short and direct response. 0.61. What is the ratio of the Gross enrolment ratio (%) of Tertiary schools in 1973 to that in 1983?
Keep it short and to the point. 0.48. What is the ratio of the Gross enrolment ratio (%) of Pre-primary schools in 1973 to that in 1984?
Offer a very short reply. 0.01. What is the ratio of the Gross enrolment ratio (%) in Primary schools in 1973 to that in 1984?
Provide a short and direct response. 1.13. What is the ratio of the Gross enrolment ratio (%) in Secondary schools in 1973 to that in 1984?
Offer a very short reply. 0.63. What is the ratio of the Gross enrolment ratio (%) in Tertiary schools in 1973 to that in 1984?
Offer a terse response. 0.23. What is the ratio of the Gross enrolment ratio (%) of Pre-primary schools in 1973 to that in 1985?
Ensure brevity in your answer.  0.02. What is the ratio of the Gross enrolment ratio (%) of Primary schools in 1973 to that in 1985?
Offer a very short reply. 1.25. What is the ratio of the Gross enrolment ratio (%) of Secondary schools in 1973 to that in 1985?
Offer a terse response. 0.43. What is the ratio of the Gross enrolment ratio (%) of Tertiary schools in 1973 to that in 1985?
Offer a terse response. 0.22. What is the ratio of the Gross enrolment ratio (%) of Pre-primary schools in 1982 to that in 1983?
Provide a succinct answer. 0.76. What is the ratio of the Gross enrolment ratio (%) in Primary schools in 1982 to that in 1983?
Offer a terse response. 1.05. What is the ratio of the Gross enrolment ratio (%) in Secondary schools in 1982 to that in 1983?
Give a very brief answer. 0.78. What is the ratio of the Gross enrolment ratio (%) of Tertiary schools in 1982 to that in 1983?
Your answer should be very brief. 0.63. What is the ratio of the Gross enrolment ratio (%) in Pre-primary schools in 1982 to that in 1984?
Offer a terse response. 0.67. What is the ratio of the Gross enrolment ratio (%) of Primary schools in 1982 to that in 1984?
Offer a very short reply. 1.16. What is the ratio of the Gross enrolment ratio (%) in Secondary schools in 1982 to that in 1984?
Give a very brief answer. 0.81. What is the ratio of the Gross enrolment ratio (%) of Tertiary schools in 1982 to that in 1984?
Your response must be concise. 0.3. What is the ratio of the Gross enrolment ratio (%) in Pre-primary schools in 1982 to that in 1985?
Make the answer very short. 0.7. What is the ratio of the Gross enrolment ratio (%) in Primary schools in 1982 to that in 1985?
Your response must be concise. 1.28. What is the ratio of the Gross enrolment ratio (%) in Secondary schools in 1982 to that in 1985?
Provide a succinct answer. 0.55. What is the ratio of the Gross enrolment ratio (%) of Tertiary schools in 1982 to that in 1985?
Your response must be concise. 0.29. What is the ratio of the Gross enrolment ratio (%) in Pre-primary schools in 1983 to that in 1984?
Offer a terse response. 0.88. What is the ratio of the Gross enrolment ratio (%) in Primary schools in 1983 to that in 1984?
Offer a very short reply. 1.1. What is the ratio of the Gross enrolment ratio (%) of Secondary schools in 1983 to that in 1984?
Make the answer very short. 1.05. What is the ratio of the Gross enrolment ratio (%) of Tertiary schools in 1983 to that in 1984?
Give a very brief answer. 0.47. What is the ratio of the Gross enrolment ratio (%) in Pre-primary schools in 1983 to that in 1985?
Keep it short and to the point. 0.92. What is the ratio of the Gross enrolment ratio (%) of Primary schools in 1983 to that in 1985?
Your answer should be compact. 1.22. What is the ratio of the Gross enrolment ratio (%) of Secondary schools in 1983 to that in 1985?
Keep it short and to the point. 0.72. What is the ratio of the Gross enrolment ratio (%) in Tertiary schools in 1983 to that in 1985?
Provide a succinct answer. 0.45. What is the ratio of the Gross enrolment ratio (%) of Pre-primary schools in 1984 to that in 1985?
Provide a short and direct response. 1.05. What is the ratio of the Gross enrolment ratio (%) of Primary schools in 1984 to that in 1985?
Ensure brevity in your answer.  1.1. What is the ratio of the Gross enrolment ratio (%) of Secondary schools in 1984 to that in 1985?
Provide a short and direct response. 0.68. What is the ratio of the Gross enrolment ratio (%) in Tertiary schools in 1984 to that in 1985?
Offer a very short reply. 0.96. What is the difference between the highest and the second highest Gross enrolment ratio (%) in Pre-primary schools?
Offer a very short reply. 0.74. What is the difference between the highest and the second highest Gross enrolment ratio (%) of Primary schools?
Your answer should be compact. 2.28. What is the difference between the highest and the second highest Gross enrolment ratio (%) in Secondary schools?
Provide a short and direct response. 1.16. What is the difference between the highest and the second highest Gross enrolment ratio (%) in Tertiary schools?
Offer a terse response. 0.01. What is the difference between the highest and the lowest Gross enrolment ratio (%) of Pre-primary schools?
Provide a short and direct response. 15.24. What is the difference between the highest and the lowest Gross enrolment ratio (%) of Primary schools?
Offer a terse response. 19.56. What is the difference between the highest and the lowest Gross enrolment ratio (%) of Secondary schools?
Provide a short and direct response. 2.44. What is the difference between the highest and the lowest Gross enrolment ratio (%) in Tertiary schools?
Provide a short and direct response. 0.15. 